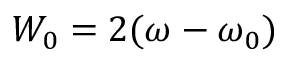Convert formula to latex. <formula><loc_0><loc_0><loc_500><loc_500>W _ { 0 } = 2 ( \omega - \omega _ { 0 } )</formula> 